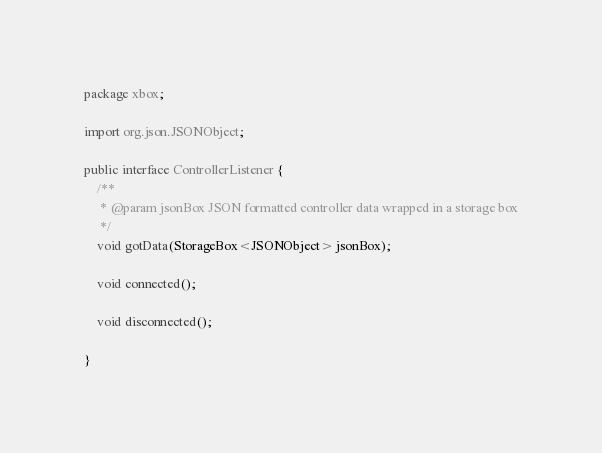Convert code to text. <code><loc_0><loc_0><loc_500><loc_500><_Java_>package xbox;

import org.json.JSONObject;

public interface ControllerListener {
    /**
     * @param jsonBox JSON formatted controller data wrapped in a storage box
     */
    void gotData(StorageBox<JSONObject> jsonBox);

    void connected();

    void disconnected();

}
</code> 